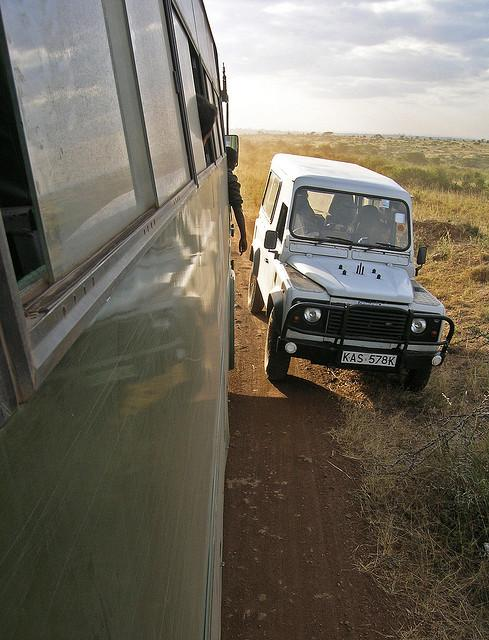In what environment are the Jeep and bus travelling?

Choices:
A) savannah
B) forest
C) desert
D) tundra savannah 